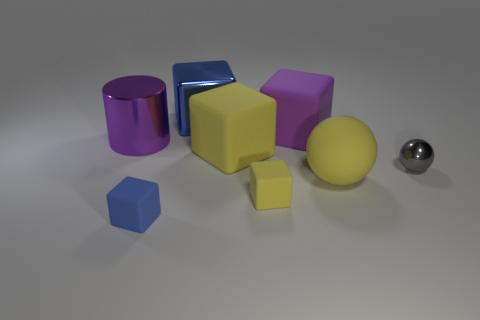Subtract 2 cubes. How many cubes are left? 3 Subtract all yellow cubes. How many cubes are left? 3 Subtract all blue matte cubes. How many cubes are left? 4 Subtract all purple blocks. Subtract all blue cylinders. How many blocks are left? 4 Add 2 brown rubber cubes. How many objects exist? 10 Subtract all spheres. How many objects are left? 6 Add 3 blue cubes. How many blue cubes exist? 5 Subtract 0 cyan cubes. How many objects are left? 8 Subtract all big yellow matte cylinders. Subtract all gray metal balls. How many objects are left? 7 Add 3 purple rubber things. How many purple rubber things are left? 4 